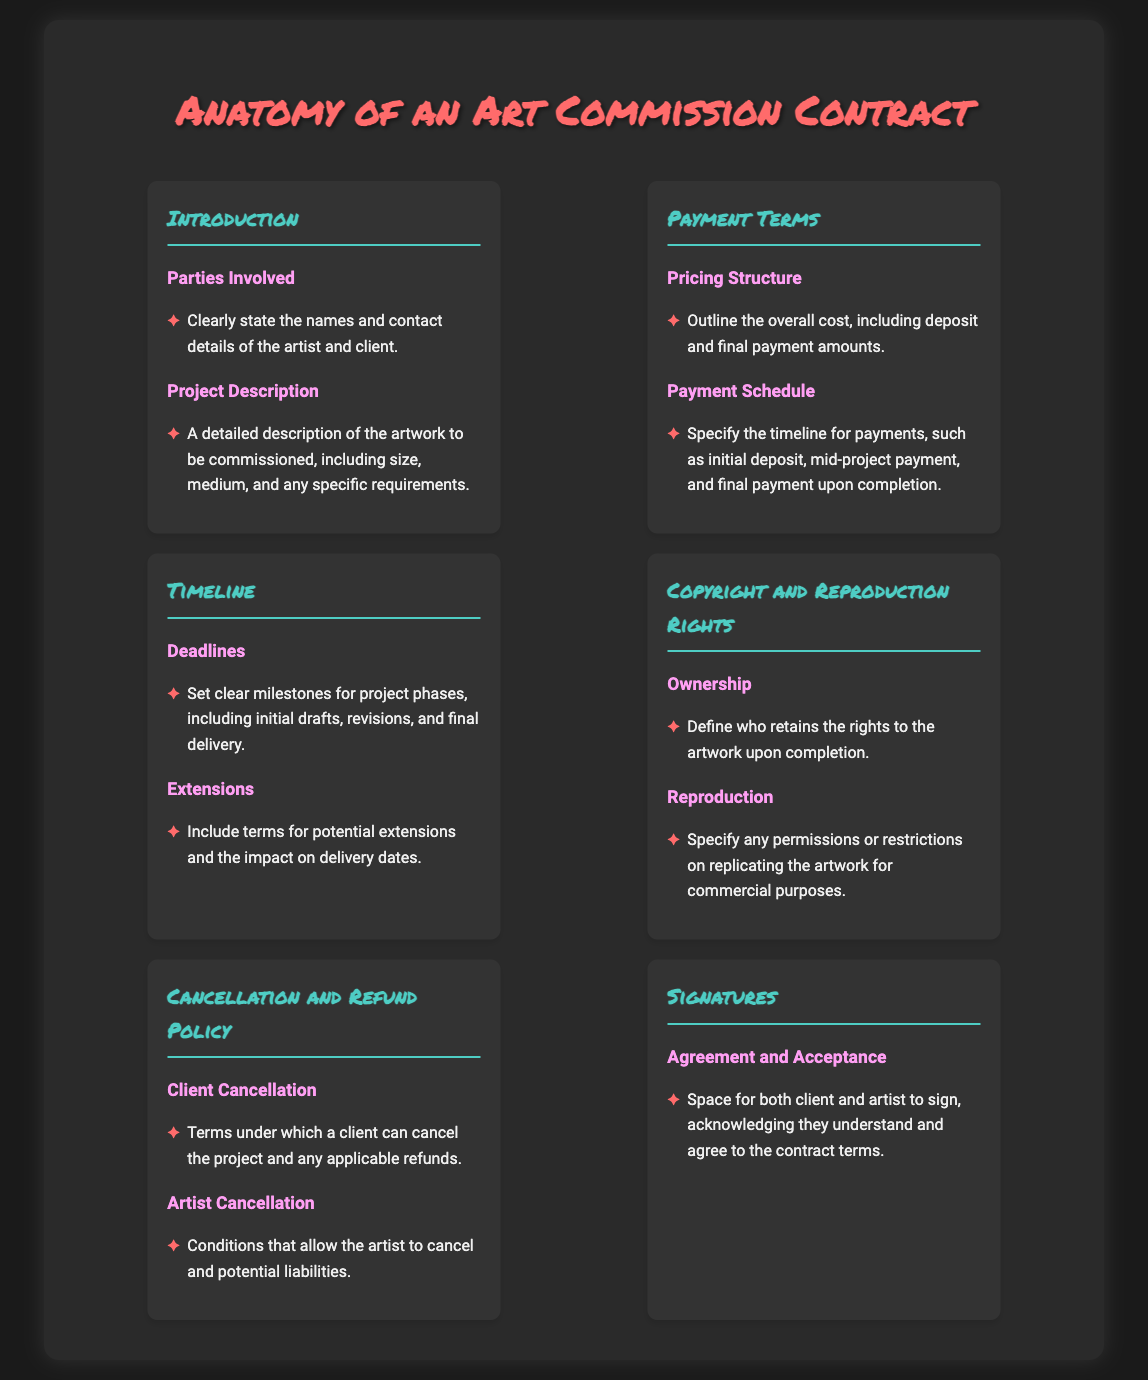what are the names of the parties involved? The names and contact details of the artist and client should be clearly stated in the contract.
Answer: artist and client what is included in the project description? The project description includes a detailed description of the artwork to be commissioned, including size, medium, and specific requirements.
Answer: artwork details what payment structure should be outlined? The overall cost, including deposit and final payment amounts, should be specified in the pricing structure.
Answer: overall cost what are the deadlines referred to in the timeline? Clear milestones for project phases, including initial drafts, revisions, and final delivery, should be set as deadlines.
Answer: project phases who retains the rights to the artwork? The ownership section defines who retains the rights to the artwork upon completion.
Answer: artist or client what happens if a client cancels? The cancellation and refund policy specifies the terms under which a client can cancel the project and any applicable refunds.
Answer: cancellation terms how is the agreement accepted? There is space for both client and artist to sign, acknowledging they understand and agree to the contract terms.
Answer: signatures what type of rights are discussed in the contract? The contract discusses copyright and reproduction rights related to the commissioned artwork.
Answer: copyright and reproduction rights how many sections are in the infographic? The infographic consists of six main sections, covering various aspects of art commission contracts.
Answer: six sections 